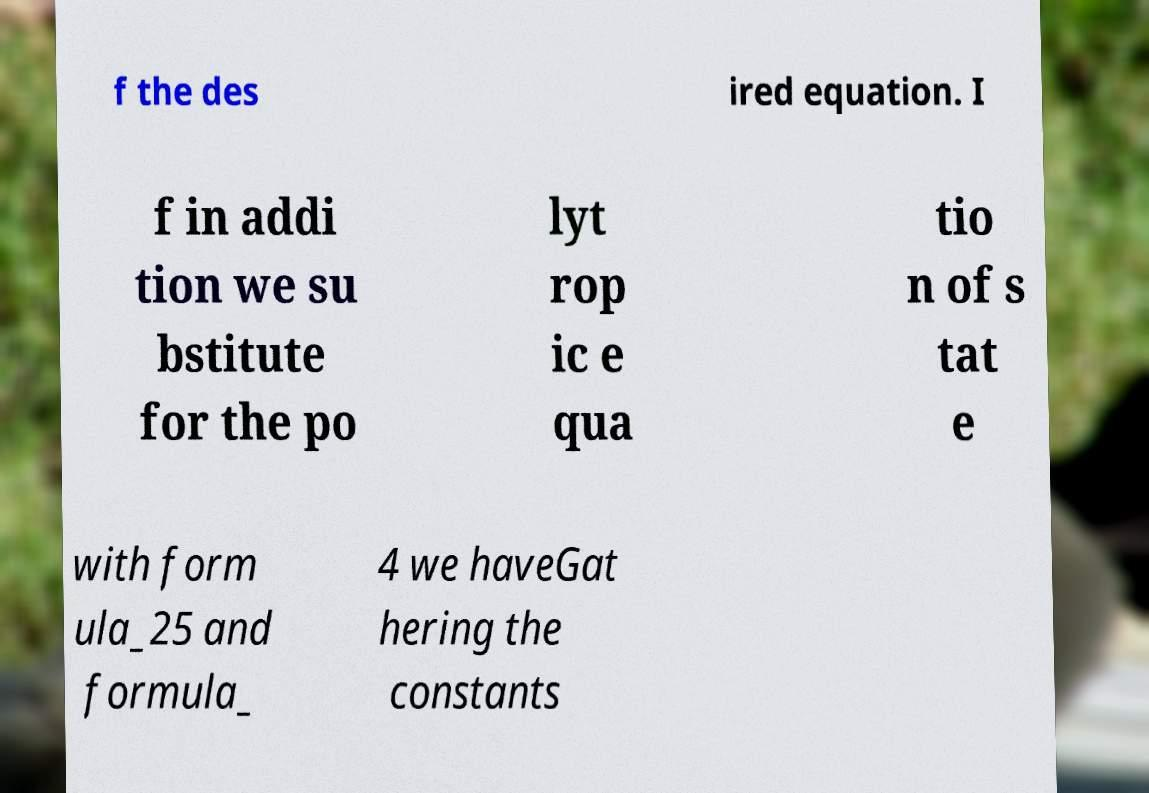Can you accurately transcribe the text from the provided image for me? f the des ired equation. I f in addi tion we su bstitute for the po lyt rop ic e qua tio n of s tat e with form ula_25 and formula_ 4 we haveGat hering the constants 